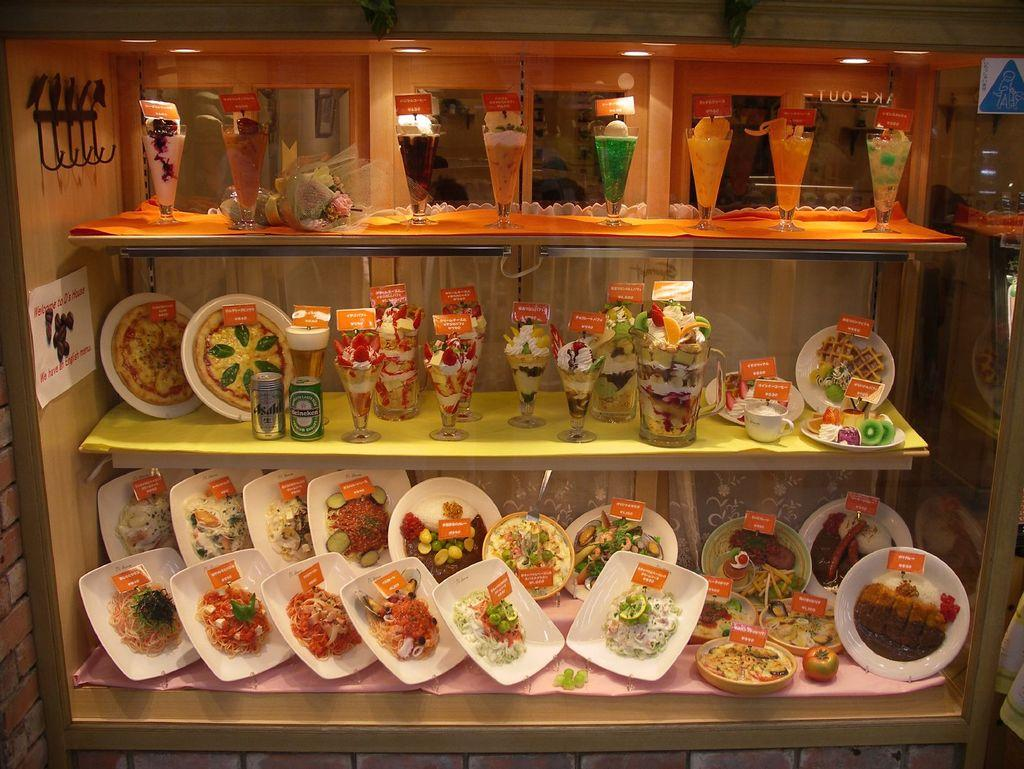What type of storage units can be seen in the image? There are shelves in the image. What is placed on the shelves? Food items are placed on the shelves. How are the food items arranged on the shelves? The food items are on plates. What else can be seen on the shelves besides food items? Glasses are present on the shelves. What page of the book is being turned in the image? There is no book present in the image, so it is not possible to determine which page is being turned. 